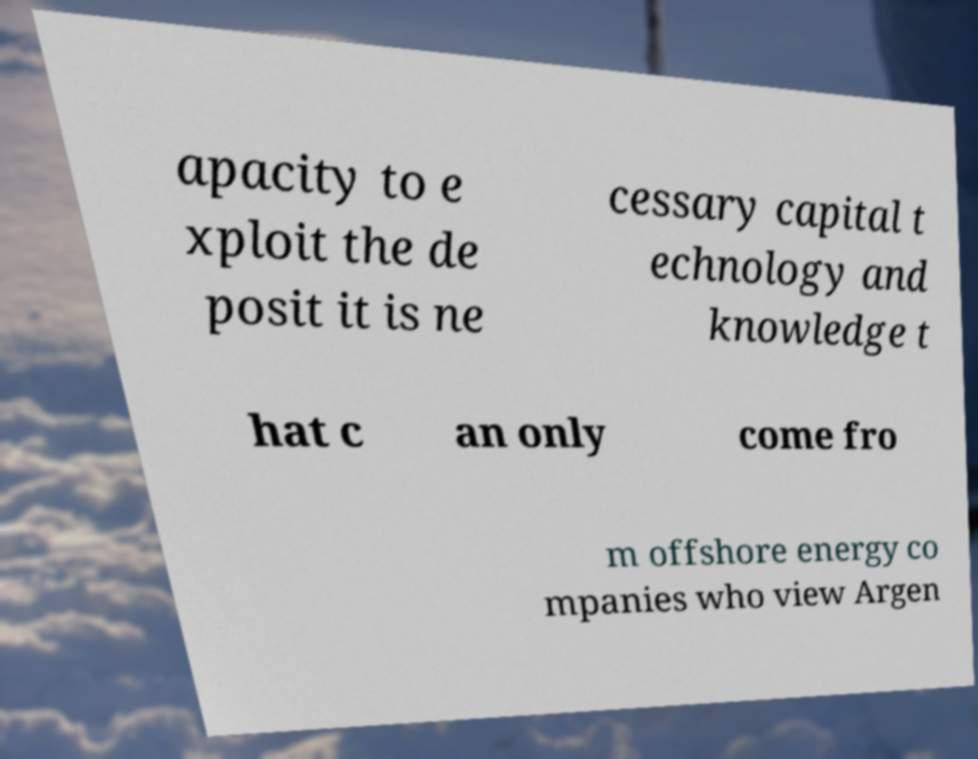Can you accurately transcribe the text from the provided image for me? apacity to e xploit the de posit it is ne cessary capital t echnology and knowledge t hat c an only come fro m offshore energy co mpanies who view Argen 